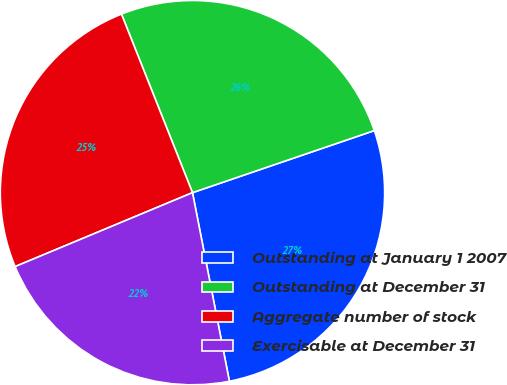<chart> <loc_0><loc_0><loc_500><loc_500><pie_chart><fcel>Outstanding at January 1 2007<fcel>Outstanding at December 31<fcel>Aggregate number of stock<fcel>Exercisable at December 31<nl><fcel>27.16%<fcel>25.79%<fcel>25.26%<fcel>21.79%<nl></chart> 